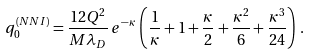<formula> <loc_0><loc_0><loc_500><loc_500>q _ { 0 } ^ { ( N N I ) } = \frac { 1 2 Q ^ { 2 } } { M \lambda _ { D } } \, e ^ { - \kappa } \, \left ( \frac { 1 } { \kappa } + 1 + \frac { \kappa } { 2 } + \frac { \kappa ^ { 2 } } { 6 } + \frac { \kappa ^ { 3 } } { 2 4 } \right ) \, .</formula> 